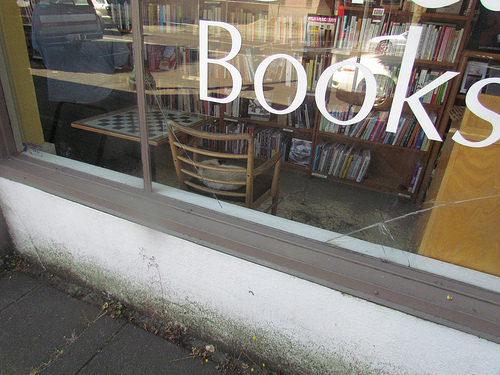<image>
Can you confirm if the books is on the window? No. The books is not positioned on the window. They may be near each other, but the books is not supported by or resting on top of the window. Is the books next to the glass? No. The books is not positioned next to the glass. They are located in different areas of the scene. 